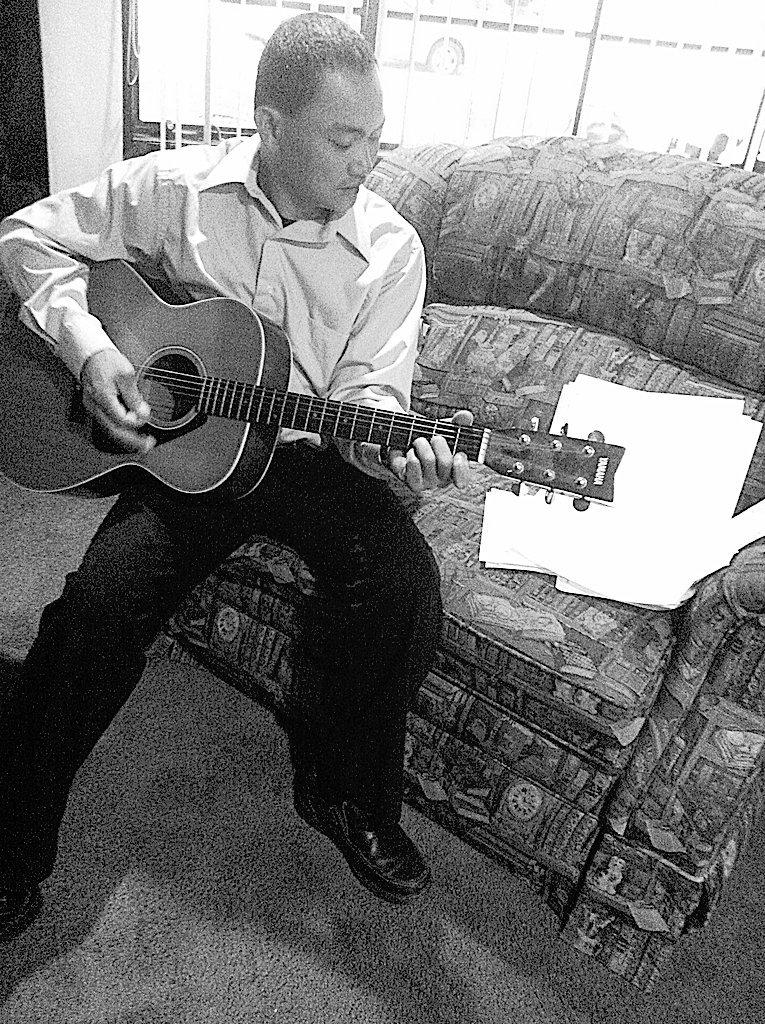What is the main subject of the image? There is a person in the image. What is the person doing in the image? The person is sitting on a sofa and playing a guitar. Can you tell me how the person is kicking a ball in the image? There is no ball present in the image, and the person is not kicking anything. 